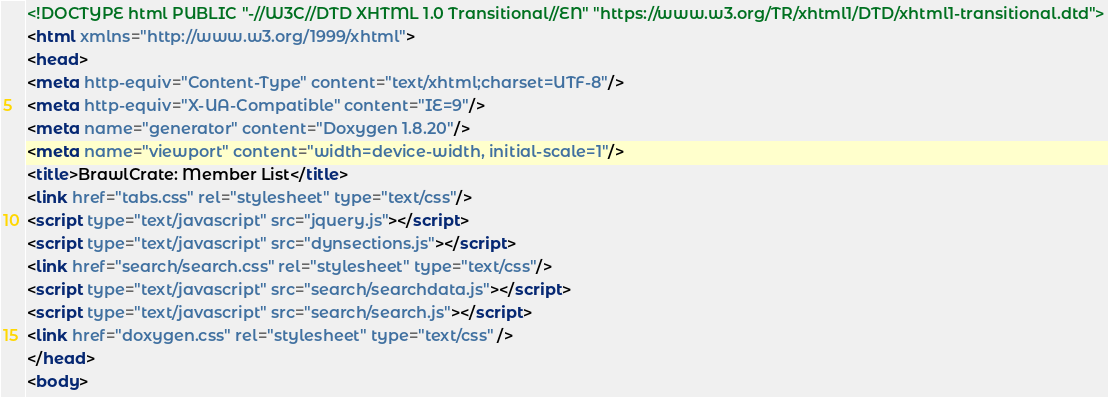Convert code to text. <code><loc_0><loc_0><loc_500><loc_500><_HTML_><!DOCTYPE html PUBLIC "-//W3C//DTD XHTML 1.0 Transitional//EN" "https://www.w3.org/TR/xhtml1/DTD/xhtml1-transitional.dtd">
<html xmlns="http://www.w3.org/1999/xhtml">
<head>
<meta http-equiv="Content-Type" content="text/xhtml;charset=UTF-8"/>
<meta http-equiv="X-UA-Compatible" content="IE=9"/>
<meta name="generator" content="Doxygen 1.8.20"/>
<meta name="viewport" content="width=device-width, initial-scale=1"/>
<title>BrawlCrate: Member List</title>
<link href="tabs.css" rel="stylesheet" type="text/css"/>
<script type="text/javascript" src="jquery.js"></script>
<script type="text/javascript" src="dynsections.js"></script>
<link href="search/search.css" rel="stylesheet" type="text/css"/>
<script type="text/javascript" src="search/searchdata.js"></script>
<script type="text/javascript" src="search/search.js"></script>
<link href="doxygen.css" rel="stylesheet" type="text/css" />
</head>
<body></code> 